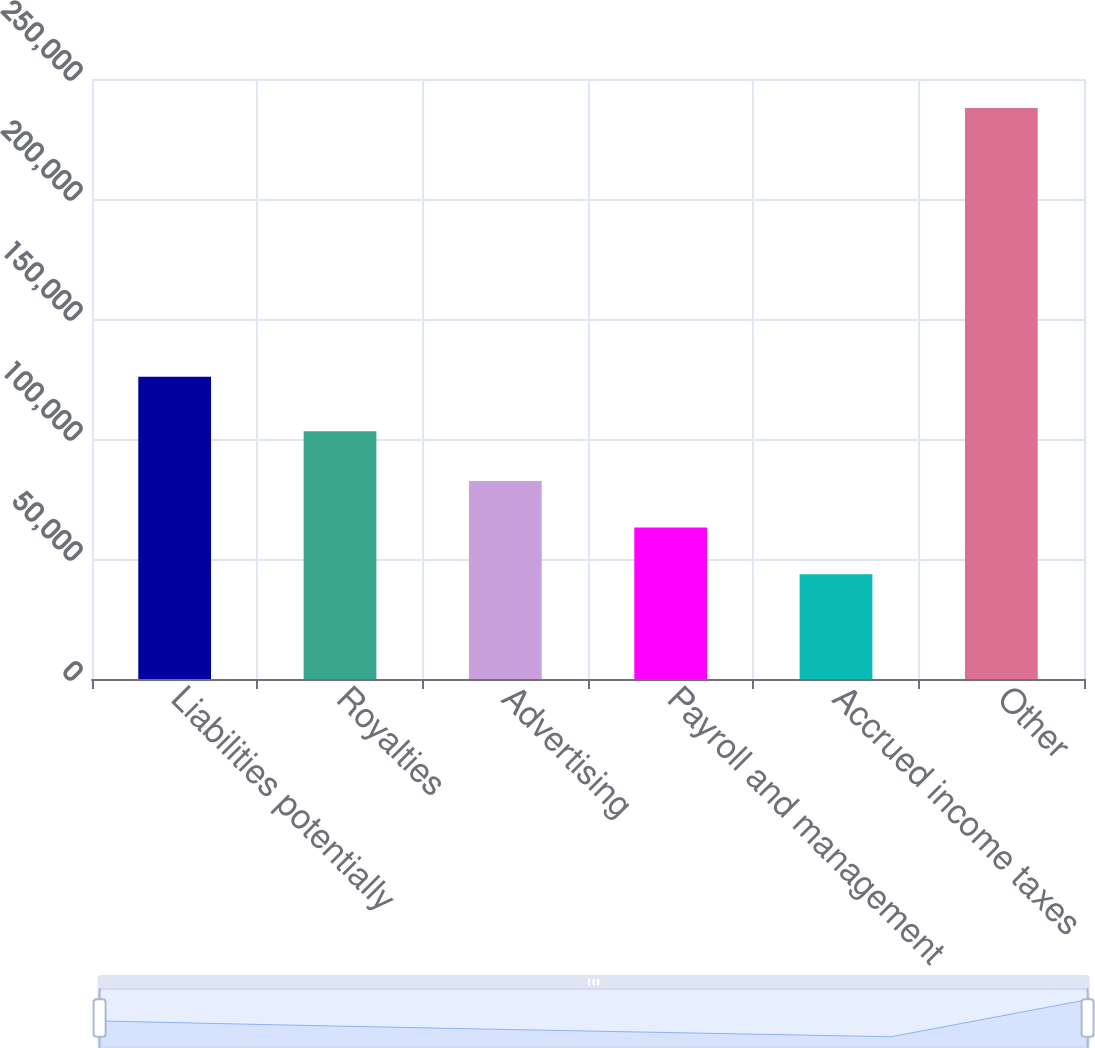<chart> <loc_0><loc_0><loc_500><loc_500><bar_chart><fcel>Liabilities potentially<fcel>Royalties<fcel>Advertising<fcel>Payroll and management<fcel>Accrued income taxes<fcel>Other<nl><fcel>125940<fcel>103206<fcel>82510.2<fcel>63079.1<fcel>43648<fcel>237959<nl></chart> 